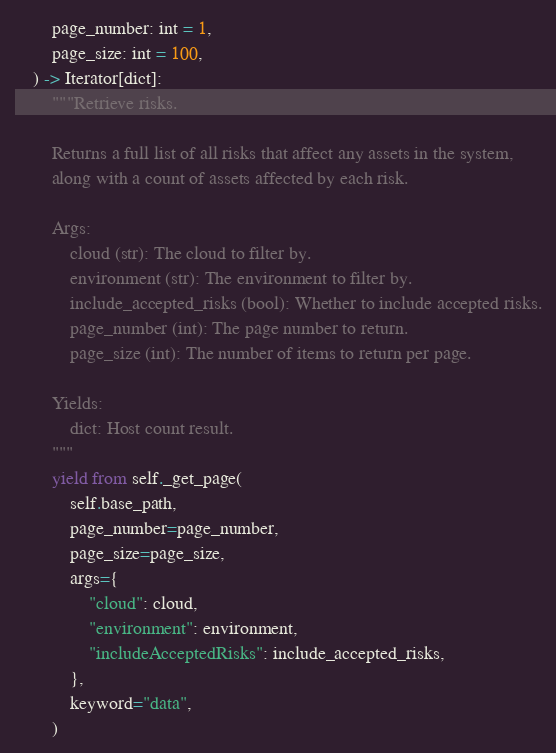Convert code to text. <code><loc_0><loc_0><loc_500><loc_500><_Python_>        page_number: int = 1,
        page_size: int = 100,
    ) -> Iterator[dict]:
        """Retrieve risks.

        Returns a full list of all risks that affect any assets in the system,
        along with a count of assets affected by each risk.

        Args:
            cloud (str): The cloud to filter by.
            environment (str): The environment to filter by.
            include_accepted_risks (bool): Whether to include accepted risks.
            page_number (int): The page number to return.
            page_size (int): The number of items to return per page.

        Yields:
            dict: Host count result.
        """
        yield from self._get_page(
            self.base_path,
            page_number=page_number,
            page_size=page_size,
            args={
                "cloud": cloud,
                "environment": environment,
                "includeAcceptedRisks": include_accepted_risks,
            },
            keyword="data",
        )
</code> 